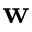Convert formula to latex. <formula><loc_0><loc_0><loc_500><loc_500>w</formula> 